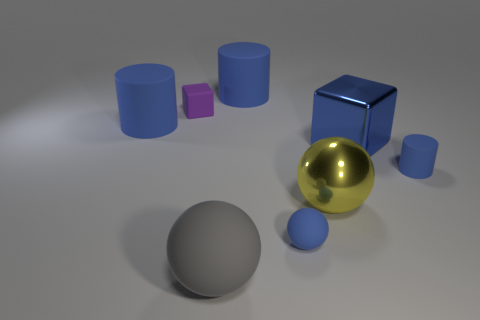There is a sphere that is the same color as the metal cube; what material is it?
Offer a terse response. Rubber. How many purple objects are either tiny cylinders or spheres?
Offer a very short reply. 0. What color is the other sphere that is made of the same material as the big gray ball?
Offer a very short reply. Blue. Is there anything else that has the same size as the blue shiny thing?
Your response must be concise. Yes. What number of small objects are either yellow balls or matte spheres?
Ensure brevity in your answer.  1. Is the number of big blue cylinders less than the number of big brown cylinders?
Ensure brevity in your answer.  No. What color is the other big thing that is the same shape as the large yellow thing?
Provide a succinct answer. Gray. Is there anything else that is the same shape as the gray rubber thing?
Your response must be concise. Yes. Is the number of big green matte cylinders greater than the number of big gray things?
Offer a very short reply. No. How many other things are the same material as the yellow sphere?
Offer a terse response. 1. 